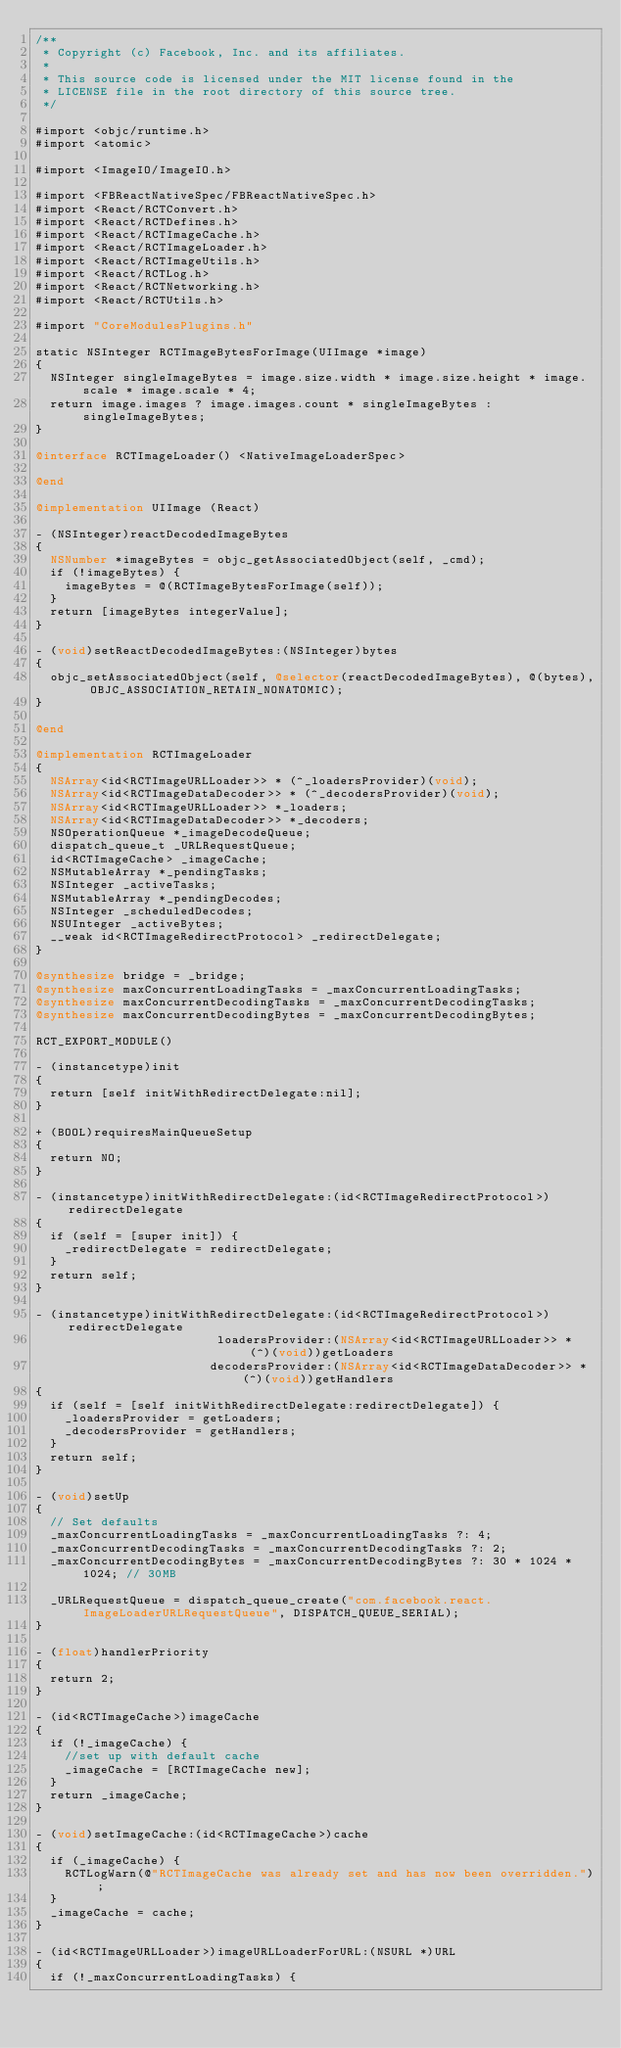<code> <loc_0><loc_0><loc_500><loc_500><_ObjectiveC_>/**
 * Copyright (c) Facebook, Inc. and its affiliates.
 *
 * This source code is licensed under the MIT license found in the
 * LICENSE file in the root directory of this source tree.
 */

#import <objc/runtime.h>
#import <atomic>

#import <ImageIO/ImageIO.h>

#import <FBReactNativeSpec/FBReactNativeSpec.h>
#import <React/RCTConvert.h>
#import <React/RCTDefines.h>
#import <React/RCTImageCache.h>
#import <React/RCTImageLoader.h>
#import <React/RCTImageUtils.h>
#import <React/RCTLog.h>
#import <React/RCTNetworking.h>
#import <React/RCTUtils.h>

#import "CoreModulesPlugins.h"

static NSInteger RCTImageBytesForImage(UIImage *image)
{
  NSInteger singleImageBytes = image.size.width * image.size.height * image.scale * image.scale * 4;
  return image.images ? image.images.count * singleImageBytes : singleImageBytes;
}

@interface RCTImageLoader() <NativeImageLoaderSpec>

@end

@implementation UIImage (React)

- (NSInteger)reactDecodedImageBytes
{
  NSNumber *imageBytes = objc_getAssociatedObject(self, _cmd);
  if (!imageBytes) {
    imageBytes = @(RCTImageBytesForImage(self));
  }
  return [imageBytes integerValue];
}

- (void)setReactDecodedImageBytes:(NSInteger)bytes
{
  objc_setAssociatedObject(self, @selector(reactDecodedImageBytes), @(bytes), OBJC_ASSOCIATION_RETAIN_NONATOMIC);
}

@end

@implementation RCTImageLoader
{
  NSArray<id<RCTImageURLLoader>> * (^_loadersProvider)(void);
  NSArray<id<RCTImageDataDecoder>> * (^_decodersProvider)(void);
  NSArray<id<RCTImageURLLoader>> *_loaders;
  NSArray<id<RCTImageDataDecoder>> *_decoders;
  NSOperationQueue *_imageDecodeQueue;
  dispatch_queue_t _URLRequestQueue;
  id<RCTImageCache> _imageCache;
  NSMutableArray *_pendingTasks;
  NSInteger _activeTasks;
  NSMutableArray *_pendingDecodes;
  NSInteger _scheduledDecodes;
  NSUInteger _activeBytes;
  __weak id<RCTImageRedirectProtocol> _redirectDelegate;
}

@synthesize bridge = _bridge;
@synthesize maxConcurrentLoadingTasks = _maxConcurrentLoadingTasks;
@synthesize maxConcurrentDecodingTasks = _maxConcurrentDecodingTasks;
@synthesize maxConcurrentDecodingBytes = _maxConcurrentDecodingBytes;

RCT_EXPORT_MODULE()

- (instancetype)init
{
  return [self initWithRedirectDelegate:nil];
}

+ (BOOL)requiresMainQueueSetup
{
  return NO;
}

- (instancetype)initWithRedirectDelegate:(id<RCTImageRedirectProtocol>)redirectDelegate
{
  if (self = [super init]) {
    _redirectDelegate = redirectDelegate;
  }
  return self;
}

- (instancetype)initWithRedirectDelegate:(id<RCTImageRedirectProtocol>)redirectDelegate
                         loadersProvider:(NSArray<id<RCTImageURLLoader>> * (^)(void))getLoaders
                        decodersProvider:(NSArray<id<RCTImageDataDecoder>> * (^)(void))getHandlers
{
  if (self = [self initWithRedirectDelegate:redirectDelegate]) {
    _loadersProvider = getLoaders;
    _decodersProvider = getHandlers;
  }
  return self;
}

- (void)setUp
{
  // Set defaults
  _maxConcurrentLoadingTasks = _maxConcurrentLoadingTasks ?: 4;
  _maxConcurrentDecodingTasks = _maxConcurrentDecodingTasks ?: 2;
  _maxConcurrentDecodingBytes = _maxConcurrentDecodingBytes ?: 30 * 1024 * 1024; // 30MB

  _URLRequestQueue = dispatch_queue_create("com.facebook.react.ImageLoaderURLRequestQueue", DISPATCH_QUEUE_SERIAL);
}

- (float)handlerPriority
{
  return 2;
}

- (id<RCTImageCache>)imageCache
{
  if (!_imageCache) {
    //set up with default cache
    _imageCache = [RCTImageCache new];
  }
  return _imageCache;
}

- (void)setImageCache:(id<RCTImageCache>)cache
{
  if (_imageCache) {
    RCTLogWarn(@"RCTImageCache was already set and has now been overridden.");
  }
  _imageCache = cache;
}

- (id<RCTImageURLLoader>)imageURLLoaderForURL:(NSURL *)URL
{
  if (!_maxConcurrentLoadingTasks) {</code> 